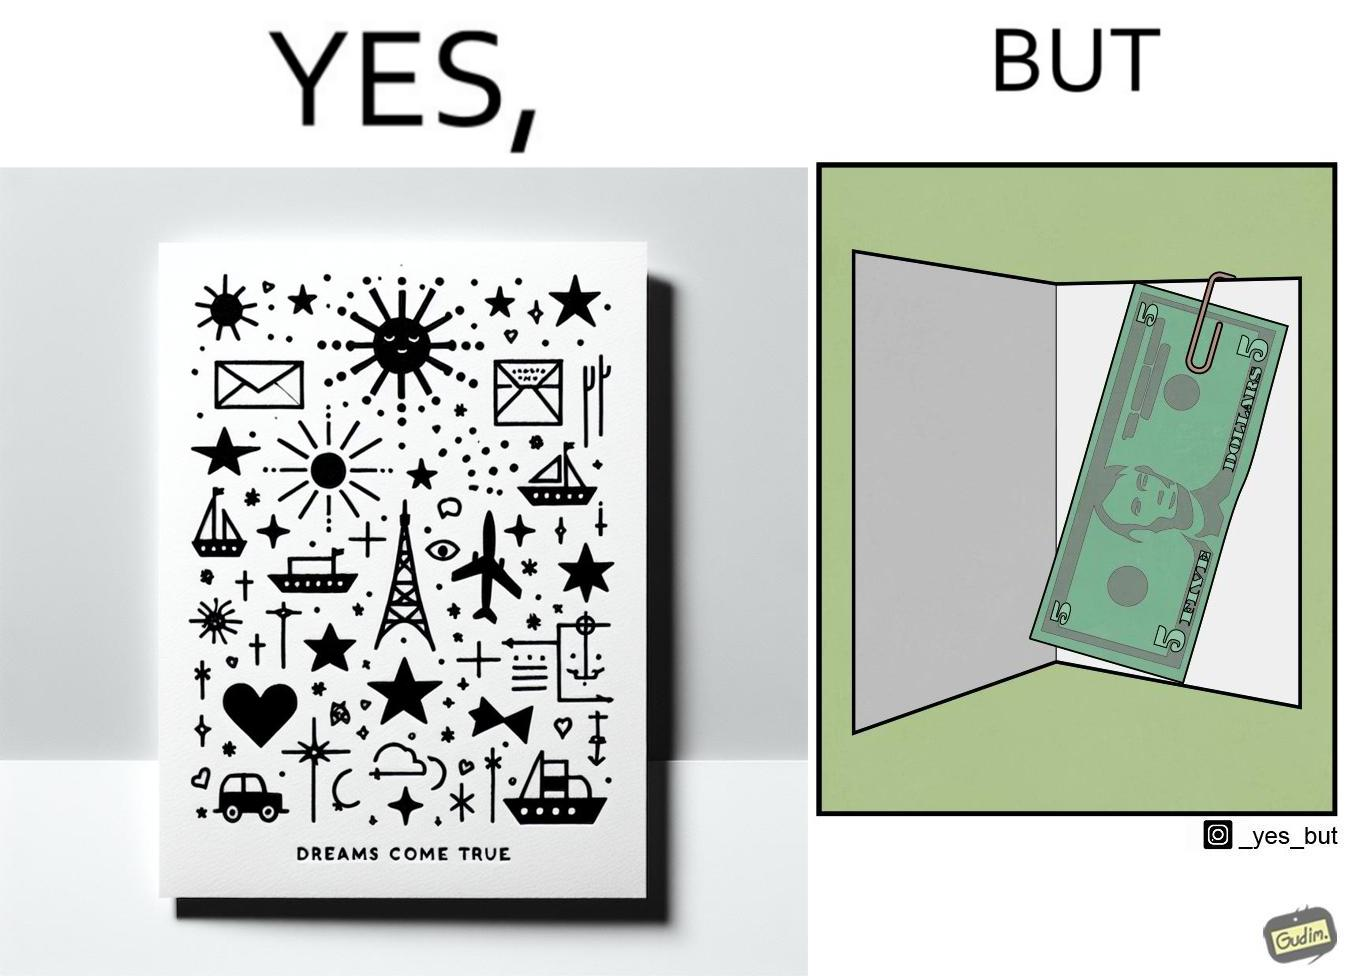Is this image satirical or non-satirical? Yes, this image is satirical. 